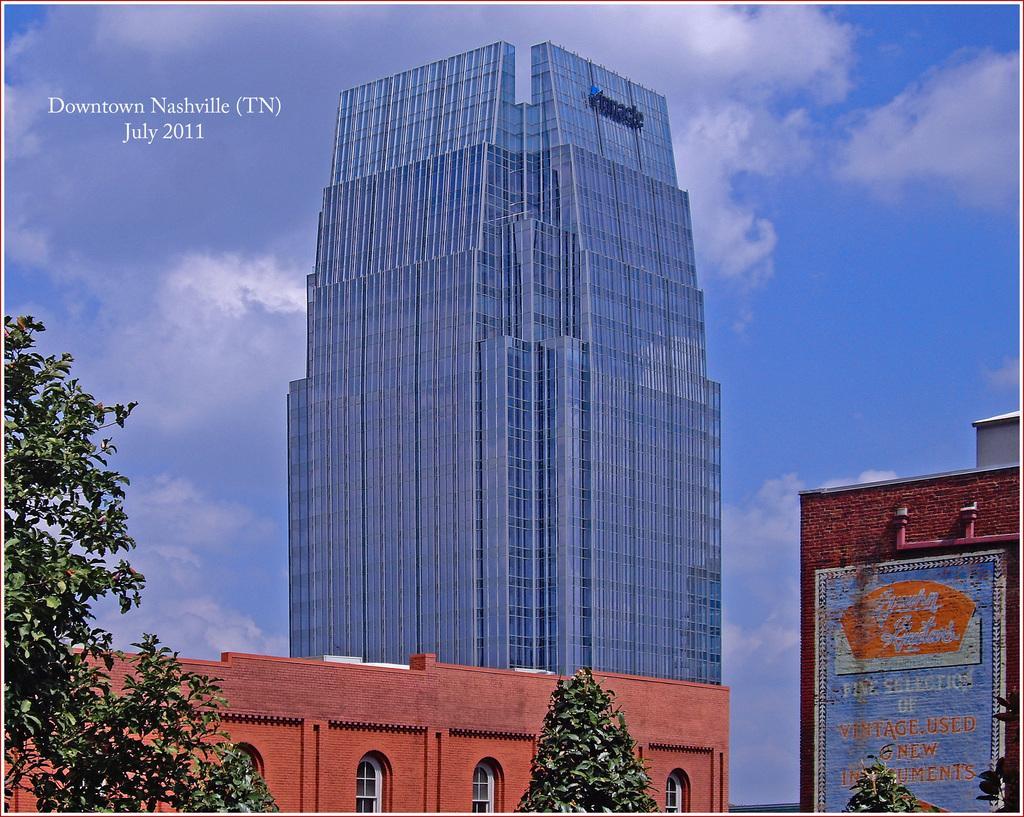How would you summarize this image in a sentence or two? In the center of the image there are buildings. There are trees. In the background of the image there is sky and clouds. 